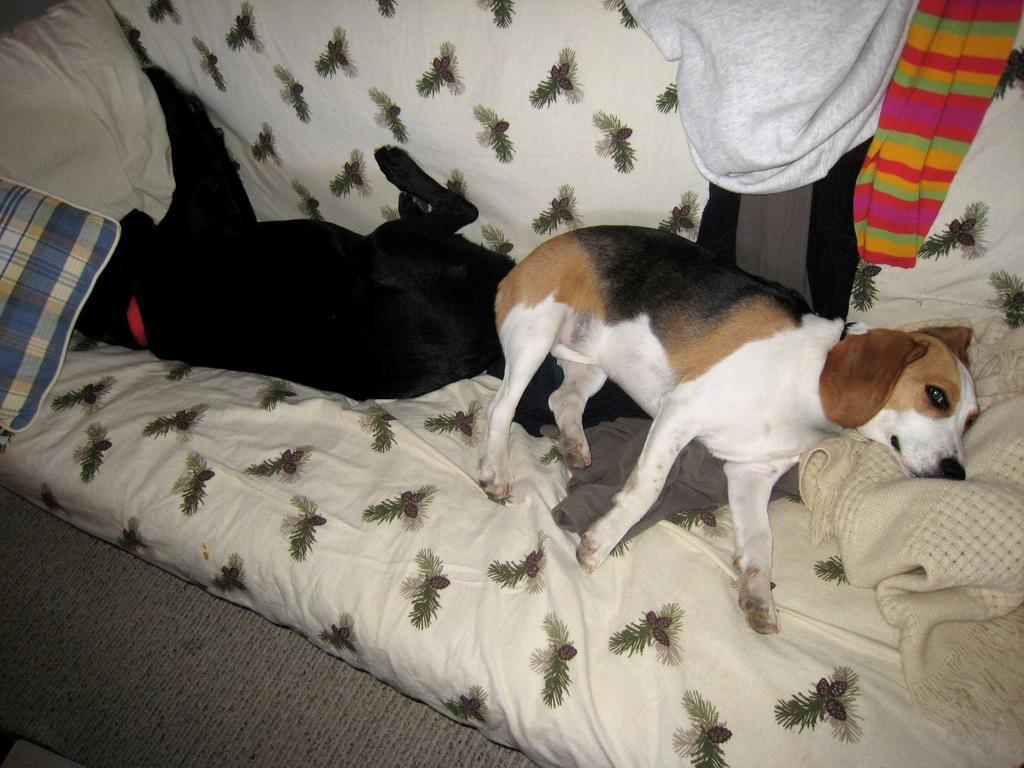Please provide a concise description of this image. In this image I can see two dogs are lying on the sofa, blankets and clothes are visible. This image is taken in a room. 